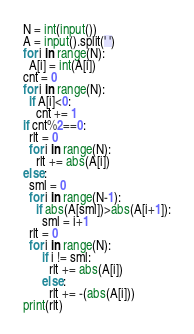<code> <loc_0><loc_0><loc_500><loc_500><_Python_>N = int(input())
A = input().split(' ')
for i in range(N):
  A[i] = int(A[i])
cnt = 0
for i in range(N):
  if A[i]<0:
    cnt += 1
if cnt%2==0:
  rlt = 0
  for i in range(N):
    rlt += abs(A[i])
else:
  sml = 0
  for i in range(N-1):
    if abs(A[sml])>abs(A[i+1]):
      sml = i+1
  rlt = 0
  for i in range(N):
      if i != sml:
        rlt += abs(A[i])
      else:
        rlt += -(abs(A[i]))
print(rlt)</code> 